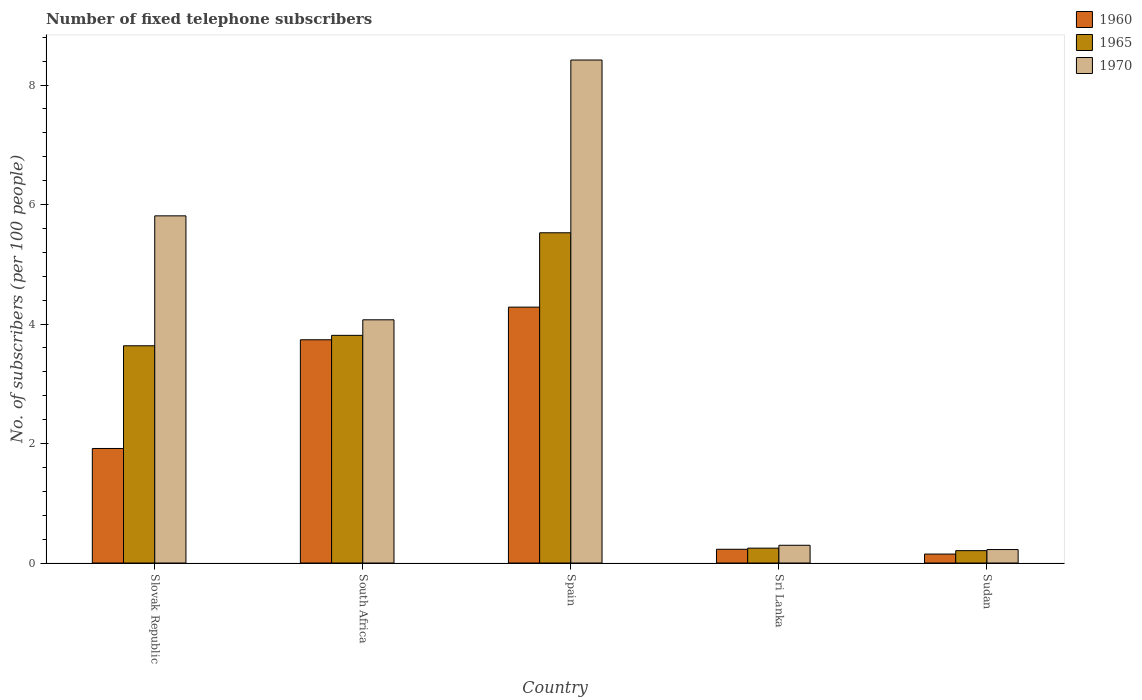How many groups of bars are there?
Provide a short and direct response. 5. Are the number of bars on each tick of the X-axis equal?
Your answer should be very brief. Yes. How many bars are there on the 3rd tick from the left?
Your response must be concise. 3. How many bars are there on the 4th tick from the right?
Offer a terse response. 3. What is the label of the 2nd group of bars from the left?
Make the answer very short. South Africa. In how many cases, is the number of bars for a given country not equal to the number of legend labels?
Your answer should be very brief. 0. What is the number of fixed telephone subscribers in 1960 in Spain?
Your answer should be very brief. 4.28. Across all countries, what is the maximum number of fixed telephone subscribers in 1970?
Keep it short and to the point. 8.42. Across all countries, what is the minimum number of fixed telephone subscribers in 1970?
Provide a succinct answer. 0.23. In which country was the number of fixed telephone subscribers in 1965 maximum?
Offer a very short reply. Spain. In which country was the number of fixed telephone subscribers in 1970 minimum?
Your answer should be compact. Sudan. What is the total number of fixed telephone subscribers in 1960 in the graph?
Keep it short and to the point. 10.32. What is the difference between the number of fixed telephone subscribers in 1970 in Slovak Republic and that in South Africa?
Your response must be concise. 1.74. What is the difference between the number of fixed telephone subscribers in 1965 in Sri Lanka and the number of fixed telephone subscribers in 1970 in Sudan?
Your answer should be very brief. 0.02. What is the average number of fixed telephone subscribers in 1965 per country?
Make the answer very short. 2.69. What is the difference between the number of fixed telephone subscribers of/in 1960 and number of fixed telephone subscribers of/in 1965 in Sri Lanka?
Keep it short and to the point. -0.02. What is the ratio of the number of fixed telephone subscribers in 1965 in Slovak Republic to that in Spain?
Offer a terse response. 0.66. Is the number of fixed telephone subscribers in 1960 in South Africa less than that in Sri Lanka?
Offer a terse response. No. What is the difference between the highest and the second highest number of fixed telephone subscribers in 1960?
Ensure brevity in your answer.  -1.82. What is the difference between the highest and the lowest number of fixed telephone subscribers in 1960?
Provide a succinct answer. 4.13. Is the sum of the number of fixed telephone subscribers in 1960 in Slovak Republic and Spain greater than the maximum number of fixed telephone subscribers in 1970 across all countries?
Give a very brief answer. No. How many bars are there?
Make the answer very short. 15. What is the difference between two consecutive major ticks on the Y-axis?
Offer a terse response. 2. Does the graph contain any zero values?
Your answer should be compact. No. Does the graph contain grids?
Your answer should be very brief. No. How many legend labels are there?
Provide a short and direct response. 3. How are the legend labels stacked?
Give a very brief answer. Vertical. What is the title of the graph?
Your response must be concise. Number of fixed telephone subscribers. Does "1983" appear as one of the legend labels in the graph?
Your response must be concise. No. What is the label or title of the Y-axis?
Offer a terse response. No. of subscribers (per 100 people). What is the No. of subscribers (per 100 people) of 1960 in Slovak Republic?
Provide a short and direct response. 1.92. What is the No. of subscribers (per 100 people) of 1965 in Slovak Republic?
Your answer should be compact. 3.64. What is the No. of subscribers (per 100 people) of 1970 in Slovak Republic?
Provide a succinct answer. 5.81. What is the No. of subscribers (per 100 people) of 1960 in South Africa?
Offer a very short reply. 3.74. What is the No. of subscribers (per 100 people) of 1965 in South Africa?
Offer a very short reply. 3.81. What is the No. of subscribers (per 100 people) in 1970 in South Africa?
Provide a succinct answer. 4.07. What is the No. of subscribers (per 100 people) in 1960 in Spain?
Provide a short and direct response. 4.28. What is the No. of subscribers (per 100 people) of 1965 in Spain?
Provide a succinct answer. 5.53. What is the No. of subscribers (per 100 people) of 1970 in Spain?
Your answer should be compact. 8.42. What is the No. of subscribers (per 100 people) of 1960 in Sri Lanka?
Offer a very short reply. 0.23. What is the No. of subscribers (per 100 people) in 1965 in Sri Lanka?
Keep it short and to the point. 0.25. What is the No. of subscribers (per 100 people) of 1970 in Sri Lanka?
Keep it short and to the point. 0.3. What is the No. of subscribers (per 100 people) of 1960 in Sudan?
Offer a very short reply. 0.15. What is the No. of subscribers (per 100 people) of 1965 in Sudan?
Provide a short and direct response. 0.21. What is the No. of subscribers (per 100 people) of 1970 in Sudan?
Provide a short and direct response. 0.23. Across all countries, what is the maximum No. of subscribers (per 100 people) in 1960?
Your answer should be very brief. 4.28. Across all countries, what is the maximum No. of subscribers (per 100 people) in 1965?
Make the answer very short. 5.53. Across all countries, what is the maximum No. of subscribers (per 100 people) in 1970?
Offer a terse response. 8.42. Across all countries, what is the minimum No. of subscribers (per 100 people) in 1960?
Ensure brevity in your answer.  0.15. Across all countries, what is the minimum No. of subscribers (per 100 people) of 1965?
Make the answer very short. 0.21. Across all countries, what is the minimum No. of subscribers (per 100 people) in 1970?
Offer a very short reply. 0.23. What is the total No. of subscribers (per 100 people) of 1960 in the graph?
Provide a succinct answer. 10.32. What is the total No. of subscribers (per 100 people) in 1965 in the graph?
Your answer should be compact. 13.43. What is the total No. of subscribers (per 100 people) of 1970 in the graph?
Your response must be concise. 18.82. What is the difference between the No. of subscribers (per 100 people) of 1960 in Slovak Republic and that in South Africa?
Your answer should be very brief. -1.82. What is the difference between the No. of subscribers (per 100 people) of 1965 in Slovak Republic and that in South Africa?
Give a very brief answer. -0.17. What is the difference between the No. of subscribers (per 100 people) of 1970 in Slovak Republic and that in South Africa?
Your answer should be compact. 1.74. What is the difference between the No. of subscribers (per 100 people) of 1960 in Slovak Republic and that in Spain?
Your answer should be very brief. -2.37. What is the difference between the No. of subscribers (per 100 people) in 1965 in Slovak Republic and that in Spain?
Give a very brief answer. -1.89. What is the difference between the No. of subscribers (per 100 people) of 1970 in Slovak Republic and that in Spain?
Make the answer very short. -2.61. What is the difference between the No. of subscribers (per 100 people) in 1960 in Slovak Republic and that in Sri Lanka?
Give a very brief answer. 1.69. What is the difference between the No. of subscribers (per 100 people) of 1965 in Slovak Republic and that in Sri Lanka?
Provide a short and direct response. 3.39. What is the difference between the No. of subscribers (per 100 people) of 1970 in Slovak Republic and that in Sri Lanka?
Provide a succinct answer. 5.51. What is the difference between the No. of subscribers (per 100 people) in 1960 in Slovak Republic and that in Sudan?
Make the answer very short. 1.77. What is the difference between the No. of subscribers (per 100 people) in 1965 in Slovak Republic and that in Sudan?
Your answer should be very brief. 3.43. What is the difference between the No. of subscribers (per 100 people) of 1970 in Slovak Republic and that in Sudan?
Provide a short and direct response. 5.58. What is the difference between the No. of subscribers (per 100 people) in 1960 in South Africa and that in Spain?
Give a very brief answer. -0.55. What is the difference between the No. of subscribers (per 100 people) in 1965 in South Africa and that in Spain?
Offer a terse response. -1.72. What is the difference between the No. of subscribers (per 100 people) in 1970 in South Africa and that in Spain?
Offer a very short reply. -4.35. What is the difference between the No. of subscribers (per 100 people) in 1960 in South Africa and that in Sri Lanka?
Your response must be concise. 3.51. What is the difference between the No. of subscribers (per 100 people) in 1965 in South Africa and that in Sri Lanka?
Provide a succinct answer. 3.56. What is the difference between the No. of subscribers (per 100 people) of 1970 in South Africa and that in Sri Lanka?
Your response must be concise. 3.77. What is the difference between the No. of subscribers (per 100 people) in 1960 in South Africa and that in Sudan?
Make the answer very short. 3.59. What is the difference between the No. of subscribers (per 100 people) of 1965 in South Africa and that in Sudan?
Give a very brief answer. 3.6. What is the difference between the No. of subscribers (per 100 people) of 1970 in South Africa and that in Sudan?
Ensure brevity in your answer.  3.85. What is the difference between the No. of subscribers (per 100 people) of 1960 in Spain and that in Sri Lanka?
Your response must be concise. 4.05. What is the difference between the No. of subscribers (per 100 people) in 1965 in Spain and that in Sri Lanka?
Make the answer very short. 5.28. What is the difference between the No. of subscribers (per 100 people) in 1970 in Spain and that in Sri Lanka?
Your response must be concise. 8.12. What is the difference between the No. of subscribers (per 100 people) in 1960 in Spain and that in Sudan?
Make the answer very short. 4.13. What is the difference between the No. of subscribers (per 100 people) in 1965 in Spain and that in Sudan?
Your answer should be compact. 5.32. What is the difference between the No. of subscribers (per 100 people) of 1970 in Spain and that in Sudan?
Offer a very short reply. 8.19. What is the difference between the No. of subscribers (per 100 people) of 1960 in Sri Lanka and that in Sudan?
Ensure brevity in your answer.  0.08. What is the difference between the No. of subscribers (per 100 people) in 1965 in Sri Lanka and that in Sudan?
Provide a succinct answer. 0.04. What is the difference between the No. of subscribers (per 100 people) of 1970 in Sri Lanka and that in Sudan?
Ensure brevity in your answer.  0.07. What is the difference between the No. of subscribers (per 100 people) in 1960 in Slovak Republic and the No. of subscribers (per 100 people) in 1965 in South Africa?
Offer a very short reply. -1.89. What is the difference between the No. of subscribers (per 100 people) in 1960 in Slovak Republic and the No. of subscribers (per 100 people) in 1970 in South Africa?
Your answer should be very brief. -2.15. What is the difference between the No. of subscribers (per 100 people) of 1965 in Slovak Republic and the No. of subscribers (per 100 people) of 1970 in South Africa?
Offer a terse response. -0.43. What is the difference between the No. of subscribers (per 100 people) in 1960 in Slovak Republic and the No. of subscribers (per 100 people) in 1965 in Spain?
Ensure brevity in your answer.  -3.61. What is the difference between the No. of subscribers (per 100 people) in 1960 in Slovak Republic and the No. of subscribers (per 100 people) in 1970 in Spain?
Your answer should be compact. -6.5. What is the difference between the No. of subscribers (per 100 people) of 1965 in Slovak Republic and the No. of subscribers (per 100 people) of 1970 in Spain?
Offer a very short reply. -4.78. What is the difference between the No. of subscribers (per 100 people) of 1960 in Slovak Republic and the No. of subscribers (per 100 people) of 1965 in Sri Lanka?
Keep it short and to the point. 1.67. What is the difference between the No. of subscribers (per 100 people) in 1960 in Slovak Republic and the No. of subscribers (per 100 people) in 1970 in Sri Lanka?
Offer a terse response. 1.62. What is the difference between the No. of subscribers (per 100 people) in 1965 in Slovak Republic and the No. of subscribers (per 100 people) in 1970 in Sri Lanka?
Ensure brevity in your answer.  3.34. What is the difference between the No. of subscribers (per 100 people) in 1960 in Slovak Republic and the No. of subscribers (per 100 people) in 1965 in Sudan?
Offer a terse response. 1.71. What is the difference between the No. of subscribers (per 100 people) in 1960 in Slovak Republic and the No. of subscribers (per 100 people) in 1970 in Sudan?
Give a very brief answer. 1.69. What is the difference between the No. of subscribers (per 100 people) of 1965 in Slovak Republic and the No. of subscribers (per 100 people) of 1970 in Sudan?
Your answer should be very brief. 3.41. What is the difference between the No. of subscribers (per 100 people) of 1960 in South Africa and the No. of subscribers (per 100 people) of 1965 in Spain?
Your answer should be compact. -1.79. What is the difference between the No. of subscribers (per 100 people) of 1960 in South Africa and the No. of subscribers (per 100 people) of 1970 in Spain?
Give a very brief answer. -4.68. What is the difference between the No. of subscribers (per 100 people) of 1965 in South Africa and the No. of subscribers (per 100 people) of 1970 in Spain?
Your answer should be compact. -4.61. What is the difference between the No. of subscribers (per 100 people) of 1960 in South Africa and the No. of subscribers (per 100 people) of 1965 in Sri Lanka?
Provide a succinct answer. 3.49. What is the difference between the No. of subscribers (per 100 people) of 1960 in South Africa and the No. of subscribers (per 100 people) of 1970 in Sri Lanka?
Your answer should be compact. 3.44. What is the difference between the No. of subscribers (per 100 people) in 1965 in South Africa and the No. of subscribers (per 100 people) in 1970 in Sri Lanka?
Keep it short and to the point. 3.51. What is the difference between the No. of subscribers (per 100 people) of 1960 in South Africa and the No. of subscribers (per 100 people) of 1965 in Sudan?
Ensure brevity in your answer.  3.53. What is the difference between the No. of subscribers (per 100 people) in 1960 in South Africa and the No. of subscribers (per 100 people) in 1970 in Sudan?
Make the answer very short. 3.51. What is the difference between the No. of subscribers (per 100 people) of 1965 in South Africa and the No. of subscribers (per 100 people) of 1970 in Sudan?
Make the answer very short. 3.58. What is the difference between the No. of subscribers (per 100 people) in 1960 in Spain and the No. of subscribers (per 100 people) in 1965 in Sri Lanka?
Provide a short and direct response. 4.03. What is the difference between the No. of subscribers (per 100 people) of 1960 in Spain and the No. of subscribers (per 100 people) of 1970 in Sri Lanka?
Your answer should be very brief. 3.99. What is the difference between the No. of subscribers (per 100 people) of 1965 in Spain and the No. of subscribers (per 100 people) of 1970 in Sri Lanka?
Keep it short and to the point. 5.23. What is the difference between the No. of subscribers (per 100 people) in 1960 in Spain and the No. of subscribers (per 100 people) in 1965 in Sudan?
Offer a very short reply. 4.08. What is the difference between the No. of subscribers (per 100 people) in 1960 in Spain and the No. of subscribers (per 100 people) in 1970 in Sudan?
Your response must be concise. 4.06. What is the difference between the No. of subscribers (per 100 people) in 1965 in Spain and the No. of subscribers (per 100 people) in 1970 in Sudan?
Your response must be concise. 5.3. What is the difference between the No. of subscribers (per 100 people) in 1960 in Sri Lanka and the No. of subscribers (per 100 people) in 1965 in Sudan?
Your answer should be very brief. 0.02. What is the difference between the No. of subscribers (per 100 people) in 1960 in Sri Lanka and the No. of subscribers (per 100 people) in 1970 in Sudan?
Your answer should be compact. 0. What is the difference between the No. of subscribers (per 100 people) in 1965 in Sri Lanka and the No. of subscribers (per 100 people) in 1970 in Sudan?
Offer a very short reply. 0.02. What is the average No. of subscribers (per 100 people) in 1960 per country?
Provide a succinct answer. 2.06. What is the average No. of subscribers (per 100 people) of 1965 per country?
Make the answer very short. 2.69. What is the average No. of subscribers (per 100 people) in 1970 per country?
Your answer should be compact. 3.76. What is the difference between the No. of subscribers (per 100 people) in 1960 and No. of subscribers (per 100 people) in 1965 in Slovak Republic?
Ensure brevity in your answer.  -1.72. What is the difference between the No. of subscribers (per 100 people) of 1960 and No. of subscribers (per 100 people) of 1970 in Slovak Republic?
Your response must be concise. -3.89. What is the difference between the No. of subscribers (per 100 people) in 1965 and No. of subscribers (per 100 people) in 1970 in Slovak Republic?
Make the answer very short. -2.17. What is the difference between the No. of subscribers (per 100 people) in 1960 and No. of subscribers (per 100 people) in 1965 in South Africa?
Provide a succinct answer. -0.07. What is the difference between the No. of subscribers (per 100 people) of 1960 and No. of subscribers (per 100 people) of 1970 in South Africa?
Offer a terse response. -0.33. What is the difference between the No. of subscribers (per 100 people) of 1965 and No. of subscribers (per 100 people) of 1970 in South Africa?
Your answer should be compact. -0.26. What is the difference between the No. of subscribers (per 100 people) in 1960 and No. of subscribers (per 100 people) in 1965 in Spain?
Offer a terse response. -1.24. What is the difference between the No. of subscribers (per 100 people) in 1960 and No. of subscribers (per 100 people) in 1970 in Spain?
Keep it short and to the point. -4.14. What is the difference between the No. of subscribers (per 100 people) of 1965 and No. of subscribers (per 100 people) of 1970 in Spain?
Your answer should be very brief. -2.89. What is the difference between the No. of subscribers (per 100 people) in 1960 and No. of subscribers (per 100 people) in 1965 in Sri Lanka?
Your answer should be compact. -0.02. What is the difference between the No. of subscribers (per 100 people) of 1960 and No. of subscribers (per 100 people) of 1970 in Sri Lanka?
Keep it short and to the point. -0.07. What is the difference between the No. of subscribers (per 100 people) of 1965 and No. of subscribers (per 100 people) of 1970 in Sri Lanka?
Give a very brief answer. -0.05. What is the difference between the No. of subscribers (per 100 people) of 1960 and No. of subscribers (per 100 people) of 1965 in Sudan?
Offer a very short reply. -0.06. What is the difference between the No. of subscribers (per 100 people) in 1960 and No. of subscribers (per 100 people) in 1970 in Sudan?
Offer a very short reply. -0.08. What is the difference between the No. of subscribers (per 100 people) in 1965 and No. of subscribers (per 100 people) in 1970 in Sudan?
Ensure brevity in your answer.  -0.02. What is the ratio of the No. of subscribers (per 100 people) in 1960 in Slovak Republic to that in South Africa?
Give a very brief answer. 0.51. What is the ratio of the No. of subscribers (per 100 people) of 1965 in Slovak Republic to that in South Africa?
Make the answer very short. 0.95. What is the ratio of the No. of subscribers (per 100 people) of 1970 in Slovak Republic to that in South Africa?
Keep it short and to the point. 1.43. What is the ratio of the No. of subscribers (per 100 people) in 1960 in Slovak Republic to that in Spain?
Offer a very short reply. 0.45. What is the ratio of the No. of subscribers (per 100 people) in 1965 in Slovak Republic to that in Spain?
Offer a very short reply. 0.66. What is the ratio of the No. of subscribers (per 100 people) of 1970 in Slovak Republic to that in Spain?
Your answer should be very brief. 0.69. What is the ratio of the No. of subscribers (per 100 people) in 1960 in Slovak Republic to that in Sri Lanka?
Your response must be concise. 8.33. What is the ratio of the No. of subscribers (per 100 people) of 1965 in Slovak Republic to that in Sri Lanka?
Ensure brevity in your answer.  14.59. What is the ratio of the No. of subscribers (per 100 people) of 1970 in Slovak Republic to that in Sri Lanka?
Make the answer very short. 19.55. What is the ratio of the No. of subscribers (per 100 people) of 1960 in Slovak Republic to that in Sudan?
Offer a very short reply. 12.78. What is the ratio of the No. of subscribers (per 100 people) in 1965 in Slovak Republic to that in Sudan?
Give a very brief answer. 17.53. What is the ratio of the No. of subscribers (per 100 people) in 1970 in Slovak Republic to that in Sudan?
Ensure brevity in your answer.  25.76. What is the ratio of the No. of subscribers (per 100 people) in 1960 in South Africa to that in Spain?
Your response must be concise. 0.87. What is the ratio of the No. of subscribers (per 100 people) of 1965 in South Africa to that in Spain?
Your answer should be very brief. 0.69. What is the ratio of the No. of subscribers (per 100 people) in 1970 in South Africa to that in Spain?
Your answer should be compact. 0.48. What is the ratio of the No. of subscribers (per 100 people) in 1960 in South Africa to that in Sri Lanka?
Offer a very short reply. 16.24. What is the ratio of the No. of subscribers (per 100 people) in 1965 in South Africa to that in Sri Lanka?
Your answer should be very brief. 15.29. What is the ratio of the No. of subscribers (per 100 people) of 1970 in South Africa to that in Sri Lanka?
Give a very brief answer. 13.7. What is the ratio of the No. of subscribers (per 100 people) of 1960 in South Africa to that in Sudan?
Provide a short and direct response. 24.92. What is the ratio of the No. of subscribers (per 100 people) in 1965 in South Africa to that in Sudan?
Ensure brevity in your answer.  18.38. What is the ratio of the No. of subscribers (per 100 people) of 1970 in South Africa to that in Sudan?
Keep it short and to the point. 18.05. What is the ratio of the No. of subscribers (per 100 people) of 1960 in Spain to that in Sri Lanka?
Give a very brief answer. 18.61. What is the ratio of the No. of subscribers (per 100 people) of 1965 in Spain to that in Sri Lanka?
Give a very brief answer. 22.18. What is the ratio of the No. of subscribers (per 100 people) in 1970 in Spain to that in Sri Lanka?
Ensure brevity in your answer.  28.33. What is the ratio of the No. of subscribers (per 100 people) in 1960 in Spain to that in Sudan?
Your response must be concise. 28.56. What is the ratio of the No. of subscribers (per 100 people) of 1965 in Spain to that in Sudan?
Give a very brief answer. 26.65. What is the ratio of the No. of subscribers (per 100 people) in 1970 in Spain to that in Sudan?
Provide a short and direct response. 37.33. What is the ratio of the No. of subscribers (per 100 people) of 1960 in Sri Lanka to that in Sudan?
Your answer should be very brief. 1.53. What is the ratio of the No. of subscribers (per 100 people) in 1965 in Sri Lanka to that in Sudan?
Keep it short and to the point. 1.2. What is the ratio of the No. of subscribers (per 100 people) of 1970 in Sri Lanka to that in Sudan?
Offer a very short reply. 1.32. What is the difference between the highest and the second highest No. of subscribers (per 100 people) in 1960?
Make the answer very short. 0.55. What is the difference between the highest and the second highest No. of subscribers (per 100 people) in 1965?
Make the answer very short. 1.72. What is the difference between the highest and the second highest No. of subscribers (per 100 people) in 1970?
Your response must be concise. 2.61. What is the difference between the highest and the lowest No. of subscribers (per 100 people) of 1960?
Offer a terse response. 4.13. What is the difference between the highest and the lowest No. of subscribers (per 100 people) of 1965?
Your answer should be very brief. 5.32. What is the difference between the highest and the lowest No. of subscribers (per 100 people) in 1970?
Your answer should be very brief. 8.19. 